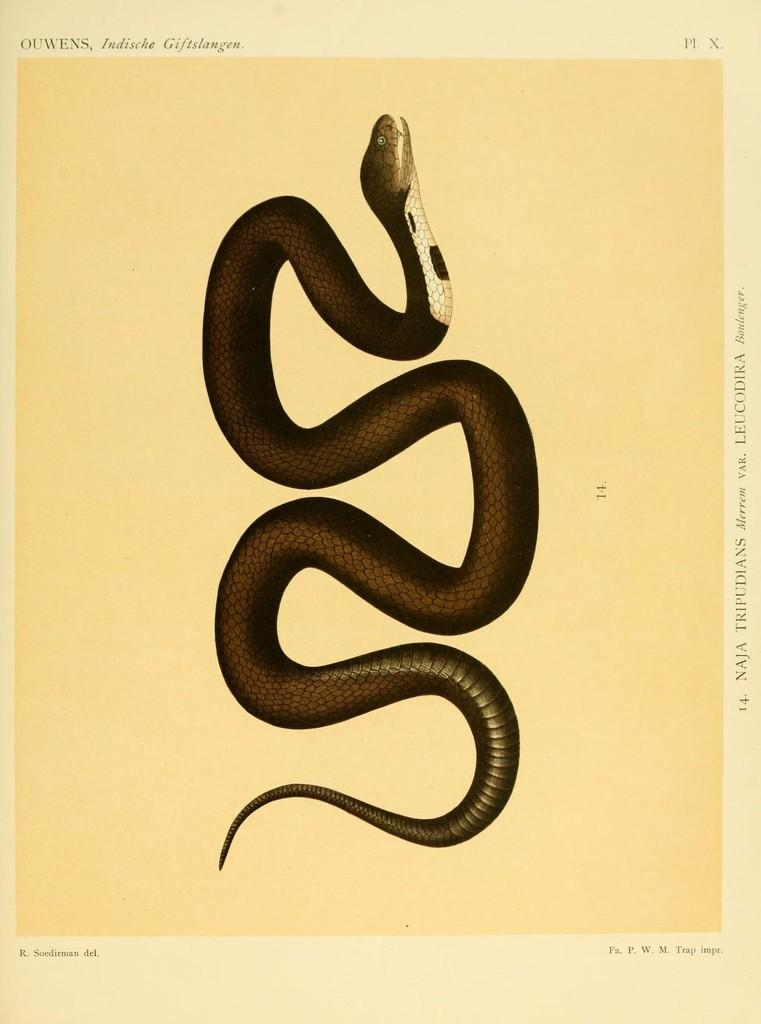What is depicted on the paper in the image? There is a drawing of a snake on the paper. What color is the snake in the drawing? The snake is in brown color. What else can be found on the paper besides the drawing of the snake? There is text written on the paper. What type of ring is the snake wearing in the image? There is no ring present on the snake in the image, as it is a drawing of a snake and not a real snake. What force is being applied to the snake in the image? There is no force being applied to the snake in the image, as it is a static drawing of a snake. 